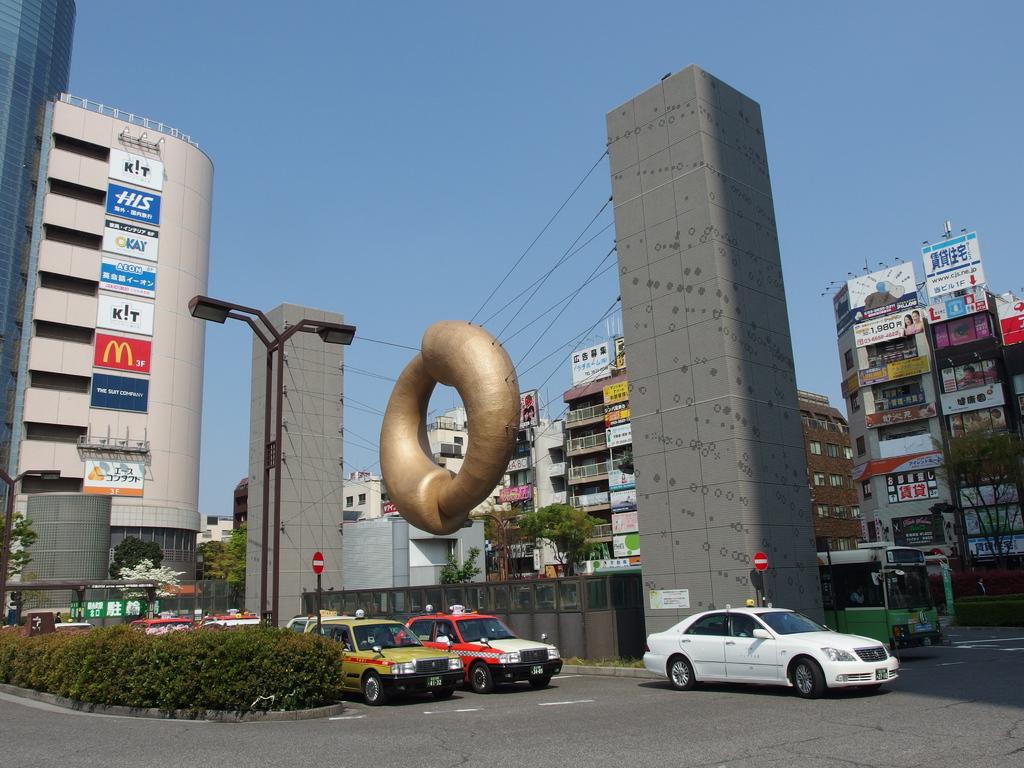What letter is written in yellow on the red sign?
Provide a succinct answer. M. What color is the car infront?
Offer a terse response. White. 